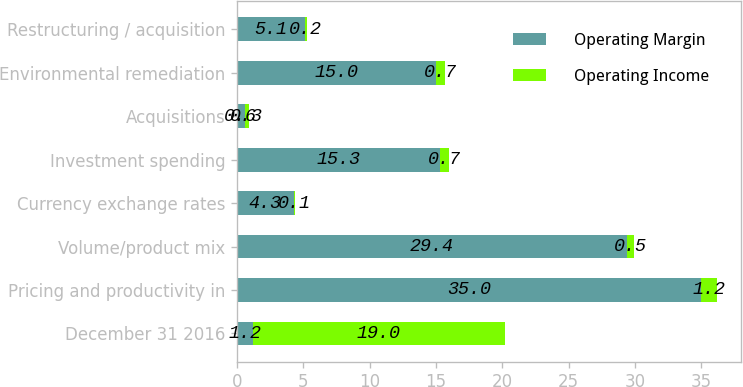Convert chart. <chart><loc_0><loc_0><loc_500><loc_500><stacked_bar_chart><ecel><fcel>December 31 2016<fcel>Pricing and productivity in<fcel>Volume/product mix<fcel>Currency exchange rates<fcel>Investment spending<fcel>Acquisitions<fcel>Environmental remediation<fcel>Restructuring / acquisition<nl><fcel>Operating Margin<fcel>1.2<fcel>35<fcel>29.4<fcel>4.3<fcel>15.3<fcel>0.6<fcel>15<fcel>5.1<nl><fcel>Operating Income<fcel>19<fcel>1.2<fcel>0.5<fcel>0.1<fcel>0.7<fcel>0.3<fcel>0.7<fcel>0.2<nl></chart> 